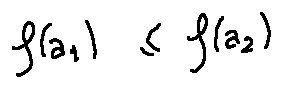<formula> <loc_0><loc_0><loc_500><loc_500>f ( a _ { 1 } ) \leq f ( a _ { 2 } )</formula> 